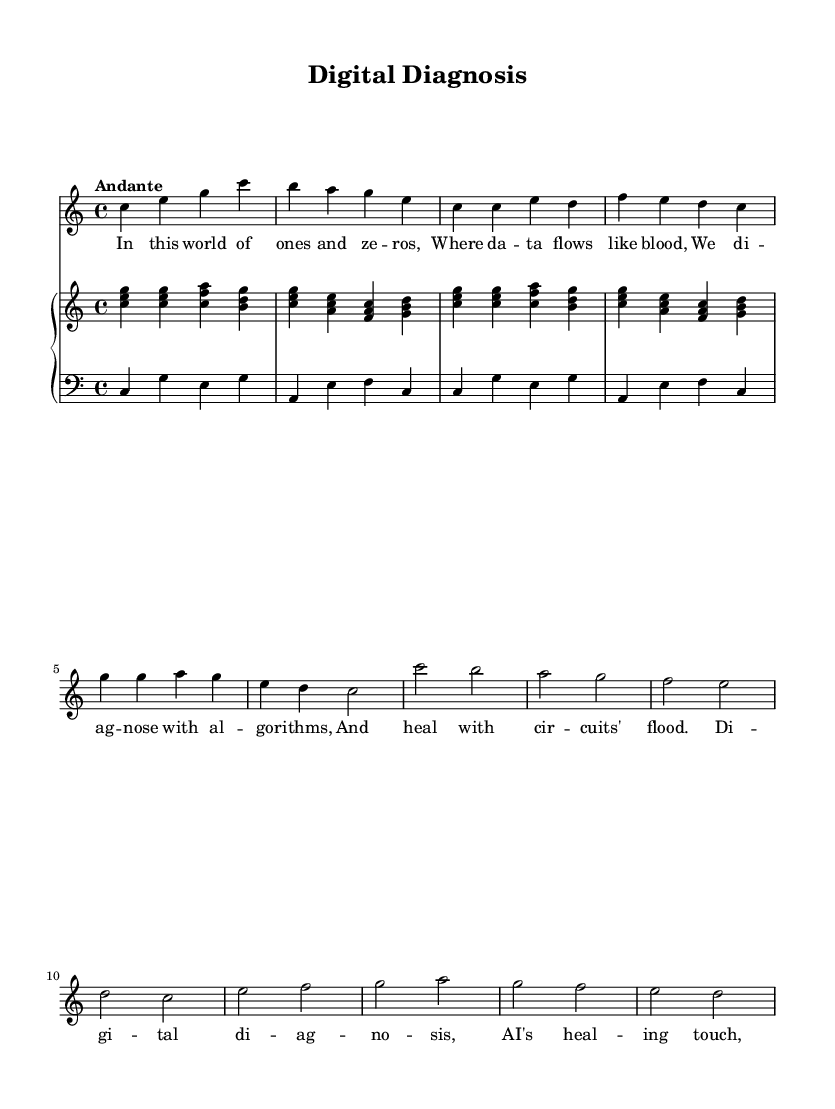What is the key signature of this music? The key signature indicated at the beginning of the staff is C major, which is represented by the absence of any sharps or flats.
Answer: C major What is the time signature of this music? The time signature appears at the beginning of the music and is written as 4/4, indicating there are four beats per measure and the quarter note represents one beat.
Answer: 4/4 What is the tempo marking for this piece? The tempo marking, found above the staff at the beginning, indicates "Andante," which suggests a moderately slow tempo.
Answer: Andante How many measures are in the soprano part? By counting the number of distinct groups of notes separated by vertical lines (measure lines) in the soprano part, it totals eight measures.
Answer: Eight What does the chorus of this opera express? The chorus lyrics reflect a theme of digital diagnosis and the integration of AI in medicine, emphasizing the synergy between technology and healthcare prevalent in the narrative.
Answer: Digital diagnosis What is the main instrument accompanying the soprano part? The accompaniment is given by a piano, which is shown as a PianoStaff with both right-hand and left-hand parts indicated.
Answer: Piano What motif is repeated in the music structure? The structure has a repeating melodic motif, evidenced by the recurrence of the phrases in both the verse and chorus, emphasizing the fusion of technology and medicine.
Answer: Repeating motif 